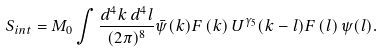<formula> <loc_0><loc_0><loc_500><loc_500>S _ { i n t } = M _ { 0 } \int \frac { d ^ { 4 } k \, d ^ { 4 } l } { ( 2 \pi ) ^ { 8 } } \bar { \psi } ( k ) F \left ( k \right ) U ^ { \gamma _ { 5 } } ( k - l ) F \left ( l \right ) \psi ( l ) .</formula> 